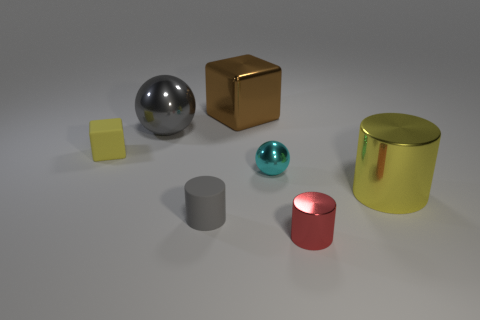Add 1 small yellow objects. How many objects exist? 8 Subtract all shiny cylinders. How many cylinders are left? 1 Subtract 1 cylinders. How many cylinders are left? 2 Subtract all cylinders. How many objects are left? 4 Subtract 1 gray cylinders. How many objects are left? 6 Subtract all cyan spheres. Subtract all red cylinders. How many spheres are left? 1 Subtract all large brown blocks. Subtract all large brown cubes. How many objects are left? 5 Add 1 small cyan metal balls. How many small cyan metal balls are left? 2 Add 2 metallic blocks. How many metallic blocks exist? 3 